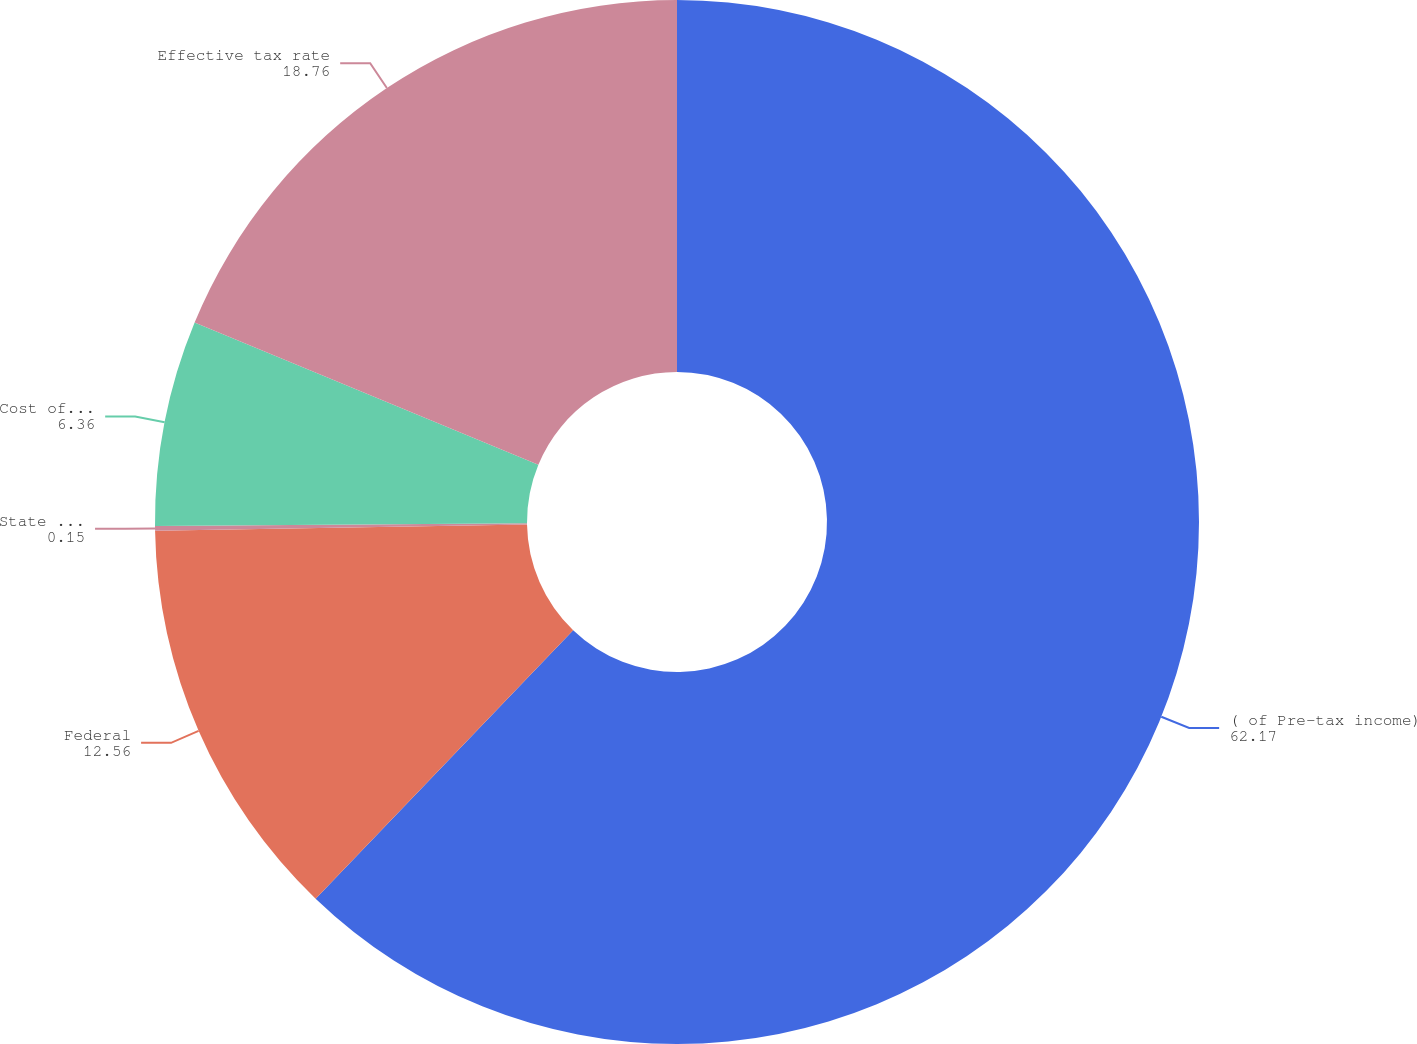Convert chart. <chart><loc_0><loc_0><loc_500><loc_500><pie_chart><fcel>( of Pre-tax income)<fcel>Federal<fcel>State income tax<fcel>Cost of removal<fcel>Effective tax rate<nl><fcel>62.17%<fcel>12.56%<fcel>0.15%<fcel>6.36%<fcel>18.76%<nl></chart> 